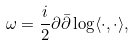<formula> <loc_0><loc_0><loc_500><loc_500>\omega = \frac { i } { 2 } \partial \bar { \partial } \log \langle \cdot , \cdot \rangle ,</formula> 